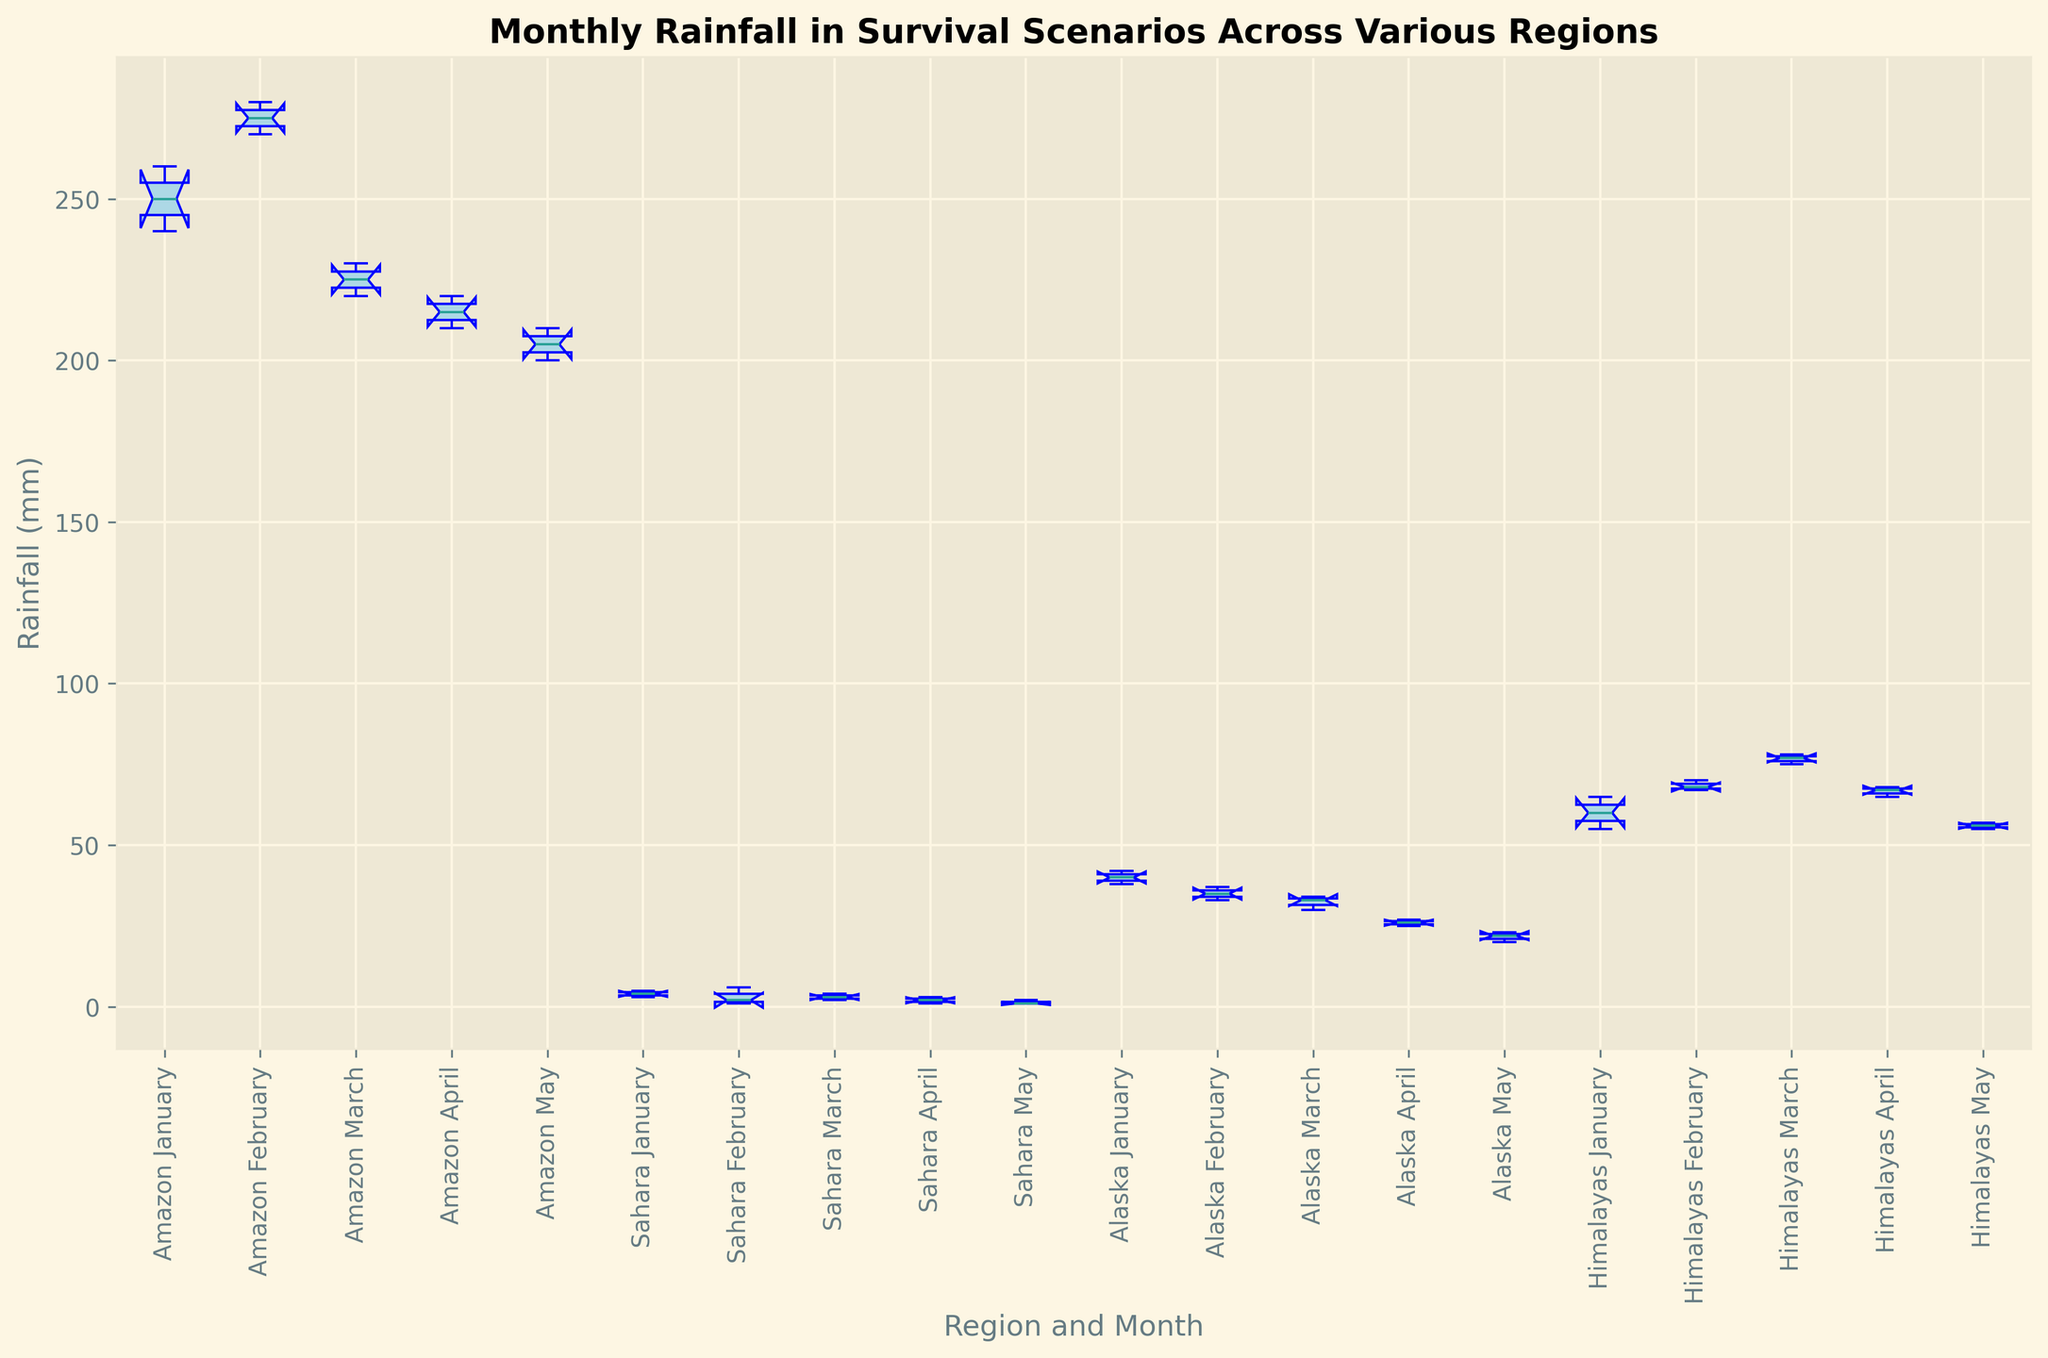What is the median rainfall in the Amazon region in January? Identify the January data points for the Amazon (240, 250, 260). The median is the middle value when sorted: 240, 250, 260. So, the median is 250.
Answer: 250 Which region has the highest variability in rainfall in February? Compare the interquartile ranges (IQR) of February data points for each region. The Amazon data ranges from 270 to 280, the Sahara from 1 to 6, Alaska from 33 to 37, and the Himalayas from 67 to 70. The Amazon has the widest spread.
Answer: Amazon Which month has the lowest median rainfall in the Sahara? For each month in the Sahara, locate the median on the box plot: January (4), February (2), March (3), April (2), May (1). The lowest median is in May.
Answer: May What is the range of the rainfall in Alaska in March? Identify the minimum and maximum rainfall values in March for Alaska: 30 to 34. The range is 34 - 30 = 4.
Answer: 4 Does the Amazon or the Himalayas have a higher median rainfall in April? Compare the median values in the box plots for April: Amazon (215) and Himalayas (67). The Amazon median is higher.
Answer: Amazon In which month is the difference between the first and third quartile largest in the Amazon region? For each month in the Amazon, calculate the difference between Q1 and Q3: January (240-260), February (270-280), March (220-230), April (210-220), May (200-210). The largest difference is in February and January.
Answer: January and February Which region has the least consistent rainfall distribution in January? Look for the month in January and compare the interquartile ranges (IQRs) for each region: Amazon has 240 to 260, Sahara has 3 to 5, Alaska has 38 to 42, and Himalayas has 55 to 65. The Amazon has the widest IQR, indicating the least consistency.
Answer: Amazon Is the median rainfall in the Himalayas higher in February or March? Compare the median values for the Himalayas in February (68) and March (77). The median rainfall is higher in March.
Answer: March What is the interquartile range of rainfall in Alaska in January? For January in Alaska, find Q1 and Q3: Q1 is 38, Q3 is 42. The interquartile range is 42 - 38 = 4.
Answer: 4 Which region experienced the least rainfall variability in May? Compare the ranges (difference between the maximum and minimum) for May rainfall: Amazon (200-210), Sahara (1-2), Alaska (20-23), Himalayas (55-57). The Sahara has the least variability.
Answer: Sahara 